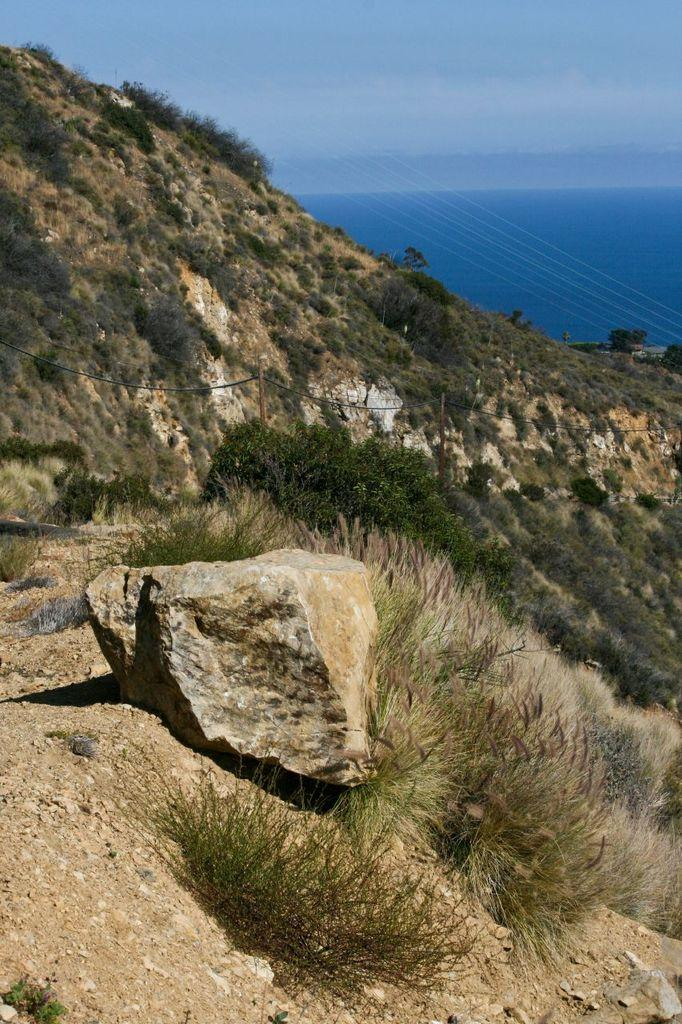What is the main subject of the image? The main subject of the image is a mountain. What features can be observed on the mountain? The mountain has trees and rocks. What can be seen in the background of the image? There is a beautiful view of the sky in the image. Who is the creator of the card in the image? There is no card present in the image, so it is not possible to determine who created it. 